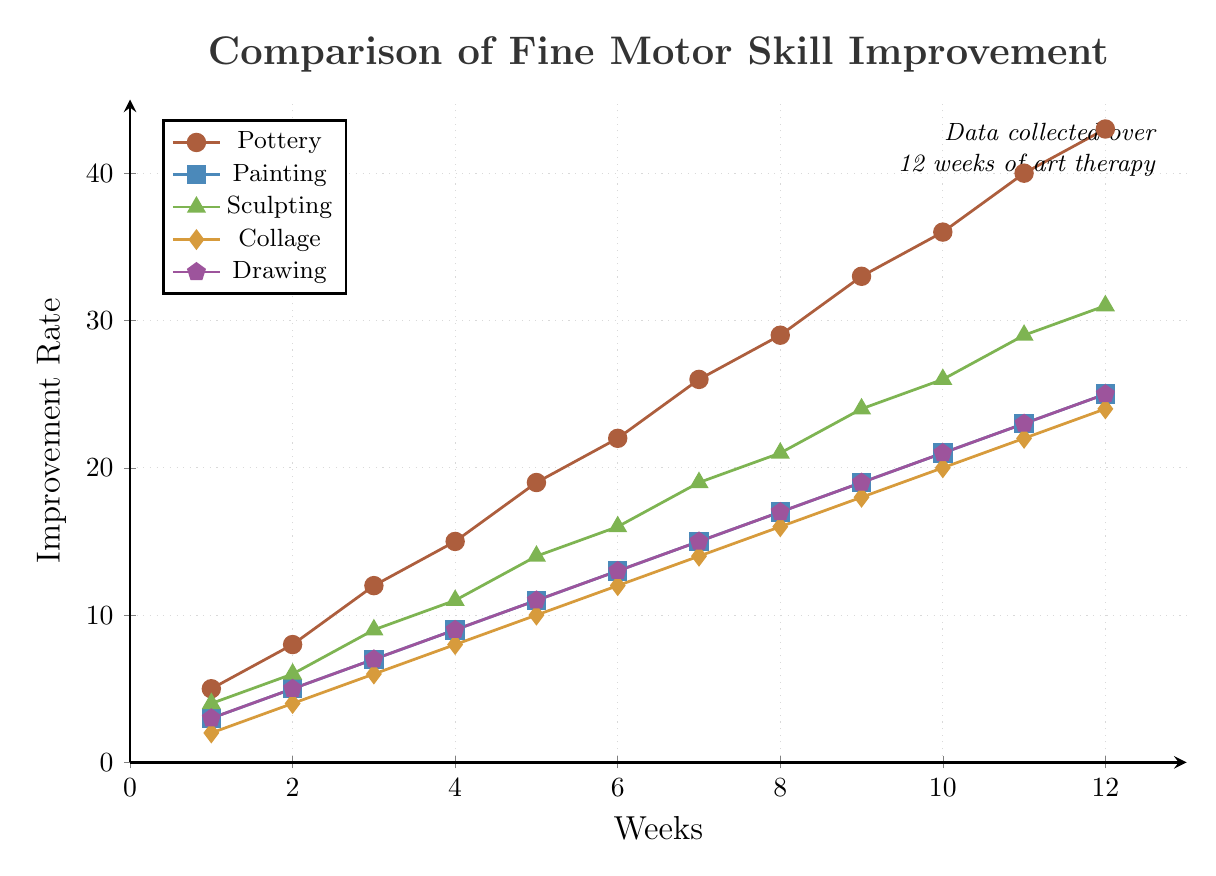What is the general trend of fine motor skill improvement in pottery over 12 weeks? The plot shows an upward trend for pottery from week 1 to week 12, indicating continuous improvement in fine motor skills throughout the therapy.
Answer: Continuous improvement Which art therapy method shows the highest improvement rate at week 6? By observing the height of the lines at week 6, pottery has the highest point (22) compared to painting (13), sculpting (16), collage (12), and drawing (13).
Answer: Pottery How does the improvement rate of collage compare to painting at week 9? At week 9, the improvement rate for collage is 18, while for painting, it is 19. Collage is slightly less than painting.
Answer: Less What is the difference in improvement rate between pottery and sculpting at week 4? At week 4, the improvement rate of pottery is 15, and sculpting is 11. The difference is 15 - 11 = 4.
Answer: 4 Is there any week where the improvement rates of painting and drawing are the same? Both painting and drawing have the same improvement rates at all weeks as visible in the plot where their corresponding lines overlap exactly.
Answer: Yes Which method shows the steepest increase in improvement from week 1 to week 12? Comparing the slopes of all lines from week 1 to week 12, pottery increases from 5 to 43, indicating it has the steepest increase compared to other methods.
Answer: Pottery What is the average improvement rate of sculpting over the 12-week period? Summing the improvement rates for sculpting from week 1 to week 12: \(4+6+9+11+14+16+19+21+24+26+29+31 = 210\). The average is \(210 / 12 ≈ 17.5\).
Answer: 17.5 At which week does pottery reach an improvement rate of 26? Observing the point where the pottery line crosses the 26 improvement rate, this occurs at week 7.
Answer: Week 7 Compare the improvement rates of all methods at the final 12th week. At week 12, pottery is 43, painting is 25, sculpting is 31, collage is 24, and drawing is 25. Pottery shows the highest improvement followed by sculpting, painting, and drawing, then collage.
Answer: Pottery > Sculpting > Painting and Drawing > Collage What is the cumulative improvement rate for collage and drawing combined at week 10? At week 10, collage has an improvement rate of 20 and drawing has 21. Combined, the rate is 20 + 21 = 41.
Answer: 41 